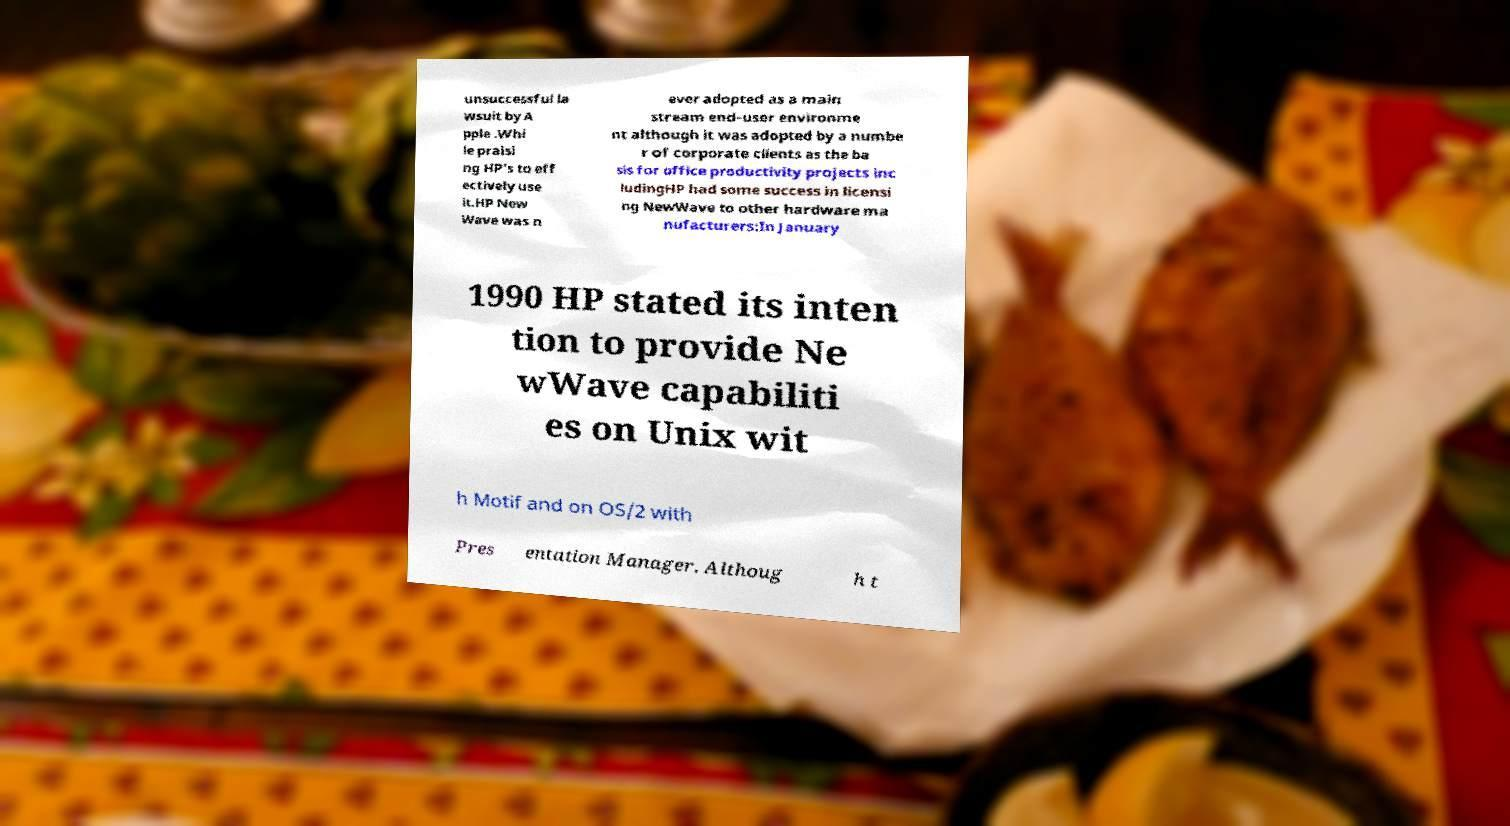What messages or text are displayed in this image? I need them in a readable, typed format. unsuccessful la wsuit by A pple .Whi le praisi ng HP's to eff ectively use it.HP New Wave was n ever adopted as a main stream end-user environme nt although it was adopted by a numbe r of corporate clients as the ba sis for office productivity projects inc ludingHP had some success in licensi ng NewWave to other hardware ma nufacturers:In January 1990 HP stated its inten tion to provide Ne wWave capabiliti es on Unix wit h Motif and on OS/2 with Pres entation Manager. Althoug h t 